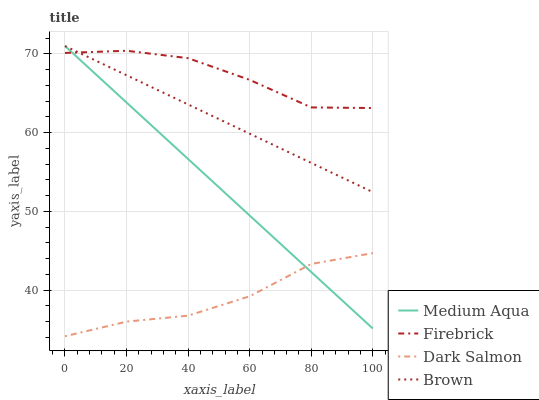Does Dark Salmon have the minimum area under the curve?
Answer yes or no. Yes. Does Firebrick have the maximum area under the curve?
Answer yes or no. Yes. Does Medium Aqua have the minimum area under the curve?
Answer yes or no. No. Does Medium Aqua have the maximum area under the curve?
Answer yes or no. No. Is Medium Aqua the smoothest?
Answer yes or no. Yes. Is Firebrick the roughest?
Answer yes or no. Yes. Is Firebrick the smoothest?
Answer yes or no. No. Is Medium Aqua the roughest?
Answer yes or no. No. Does Dark Salmon have the lowest value?
Answer yes or no. Yes. Does Medium Aqua have the lowest value?
Answer yes or no. No. Does Medium Aqua have the highest value?
Answer yes or no. Yes. Does Firebrick have the highest value?
Answer yes or no. No. Is Dark Salmon less than Brown?
Answer yes or no. Yes. Is Brown greater than Dark Salmon?
Answer yes or no. Yes. Does Dark Salmon intersect Medium Aqua?
Answer yes or no. Yes. Is Dark Salmon less than Medium Aqua?
Answer yes or no. No. Is Dark Salmon greater than Medium Aqua?
Answer yes or no. No. Does Dark Salmon intersect Brown?
Answer yes or no. No. 